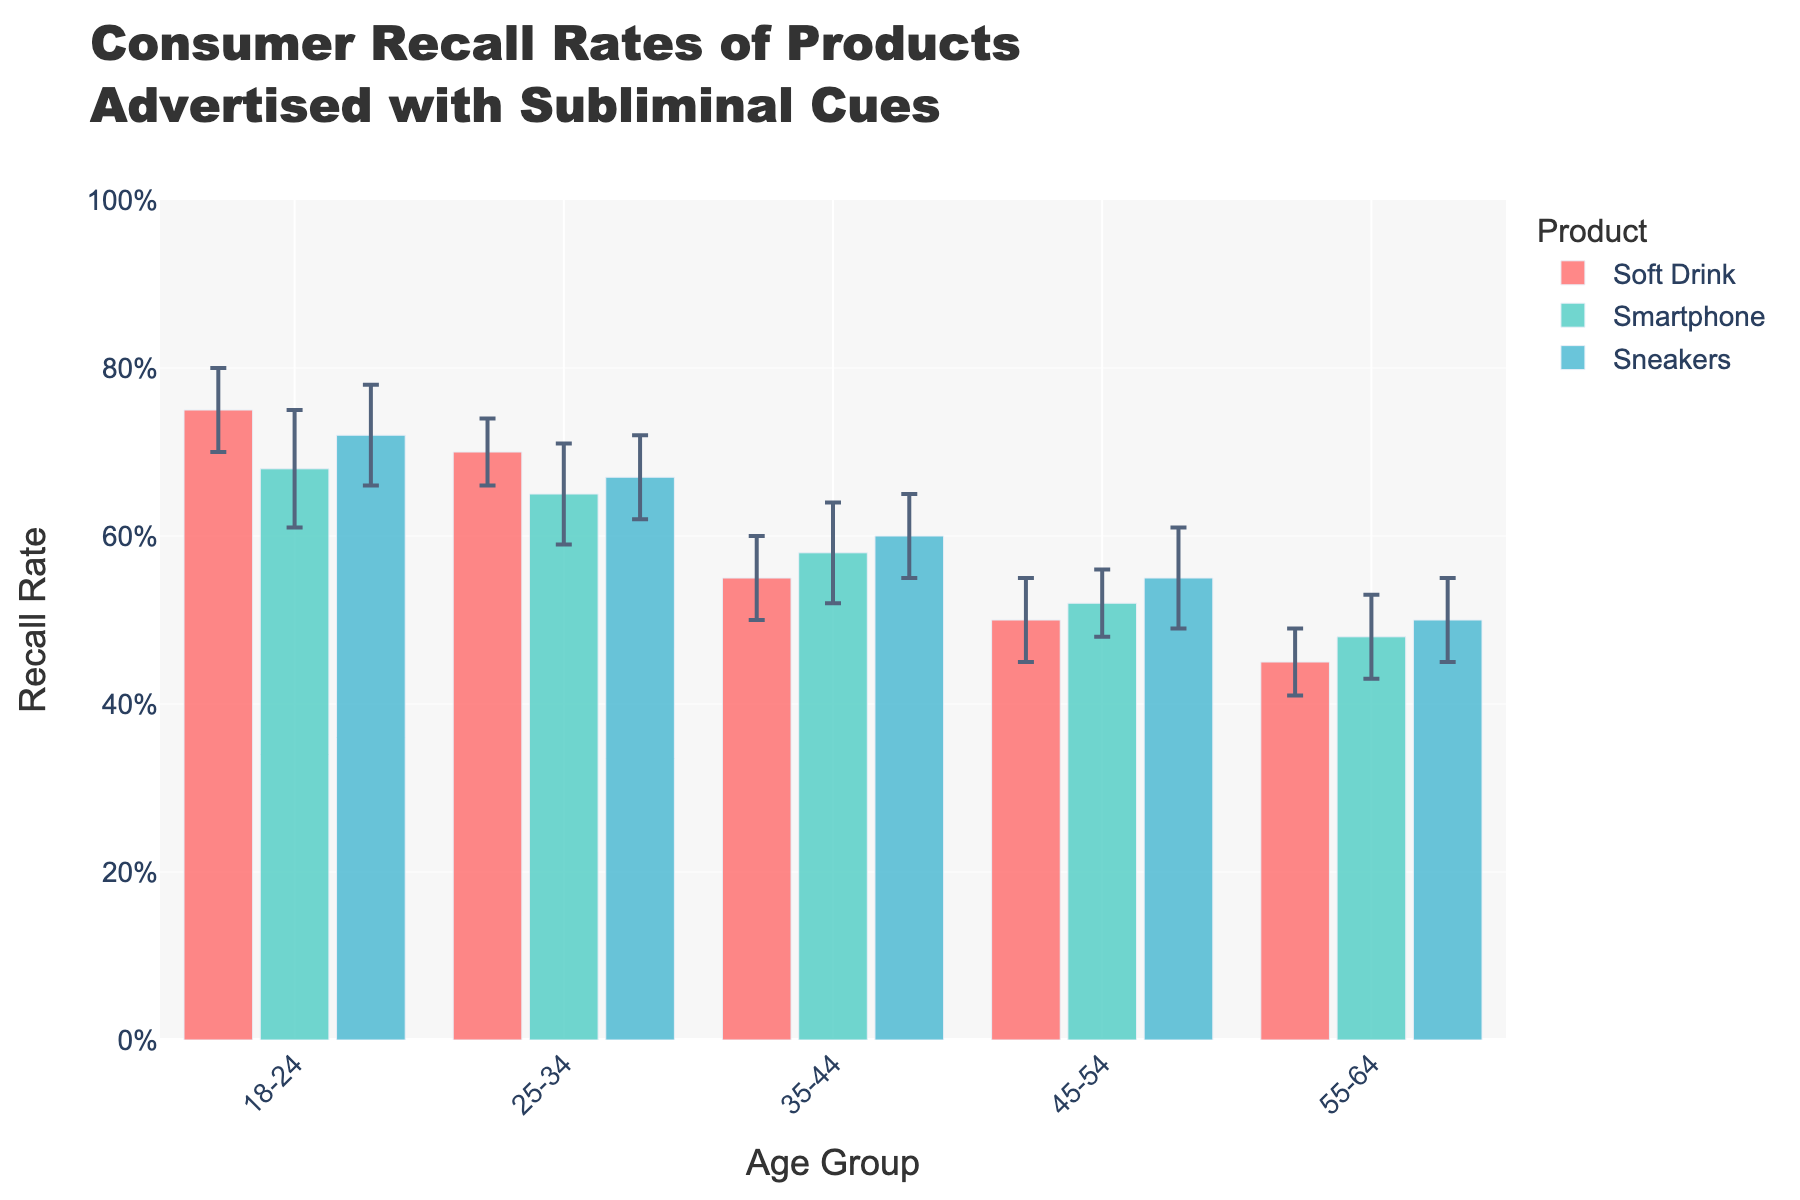What's the title of the chart? Look at the top of the chart to find the title, which usually summarizes the main topic of the data being presented.
Answer: Consumer Recall Rates of Products Advertised with Subliminal Cues Which age group has the highest recall rate for Soft Drink? Identify the bars representing Soft Drink across the age groups, find the tallest bar and note its age group.
Answer: 18-24 What is the recall rate for Sneakers in the 45-54 age group? Locate the bar for Sneakers within the 45-54 age group and refer to the height along the y-axis.
Answer: 0.55 How does the recall rate for Smartphones in the 35-44 age group compare to the 55-64 age group? Determine the heights of the bars for Smartphones in both age groups and compare their values.
Answer: Higher in 35-44 What is the average recall rate for Soft Drink across all age groups? Sum the recall rates for Soft Drink in each age group and divide by the number of groups (5): (0.75 + 0.70 + 0.55 + 0.50 + 0.45) / 5 = 2.95 / 5 = 0.59
Answer: 0.59 Which product shows the most significant decrease in recall rate from the 18-24 age group to the 55-64 age group? Calculate the difference in recall rates for each product from 18-24 to 55-64, and identify the product with the largest decrease: 
Soft Drink: 0.75 - 0.45 = 0.30 
Smartphone: 0.68 - 0.48 = 0.20 
Sneakers: 0.72 - 0.50 = 0.22
Answer: Soft Drink How does the recall rate for Sneakers in the 35-44 age group compare to the Soft Drink in the same group? Find the recall rates for Sneakers and Soft Drink in the 35-44 age group and compare their values.
Answer: Higher for Sneakers Which product has the smallest variation in recall rates across all age groups? Calculate the range (maximum - minimum) of recall rates for each product across age groups, and identify the product with the smallest range. 
Soft Drink: max = 0.75, min = 0.45, range = 0.30 
Smartphone: max = 0.68, min = 0.48, range = 0.20 
Sneakers: max = 0.72, min = 0.50, range = 0.22
Answer: Smartphone 